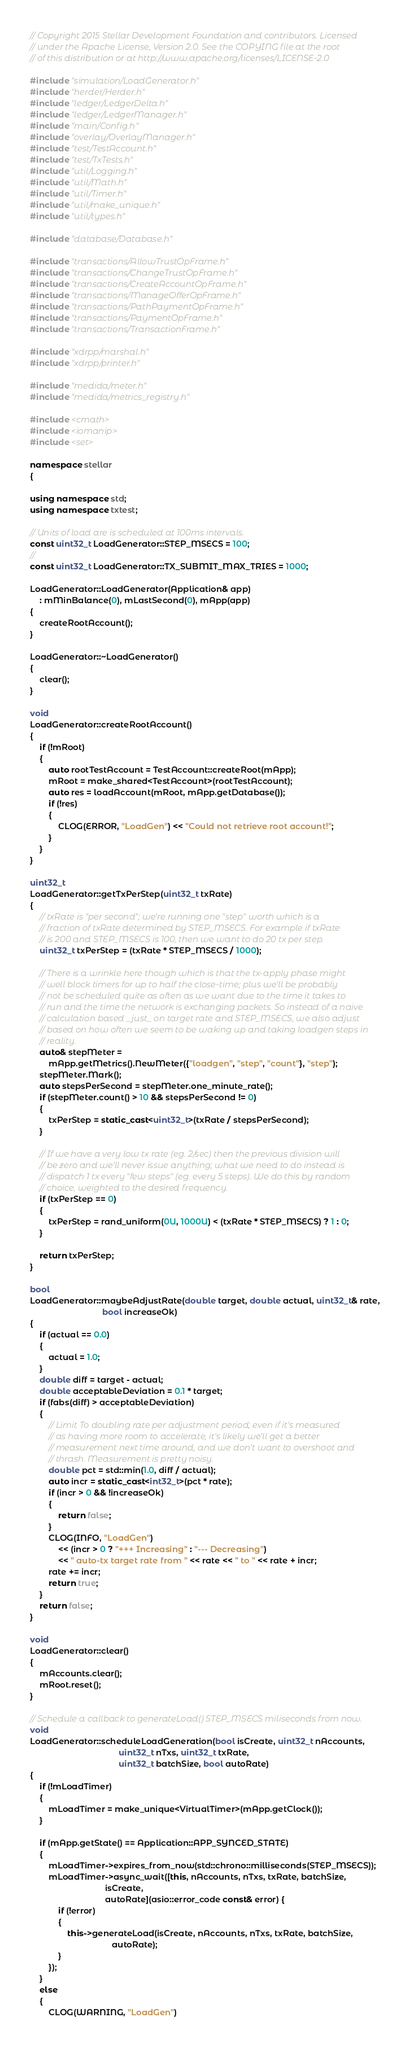<code> <loc_0><loc_0><loc_500><loc_500><_C++_>// Copyright 2015 Stellar Development Foundation and contributors. Licensed
// under the Apache License, Version 2.0. See the COPYING file at the root
// of this distribution or at http://www.apache.org/licenses/LICENSE-2.0

#include "simulation/LoadGenerator.h"
#include "herder/Herder.h"
#include "ledger/LedgerDelta.h"
#include "ledger/LedgerManager.h"
#include "main/Config.h"
#include "overlay/OverlayManager.h"
#include "test/TestAccount.h"
#include "test/TxTests.h"
#include "util/Logging.h"
#include "util/Math.h"
#include "util/Timer.h"
#include "util/make_unique.h"
#include "util/types.h"

#include "database/Database.h"

#include "transactions/AllowTrustOpFrame.h"
#include "transactions/ChangeTrustOpFrame.h"
#include "transactions/CreateAccountOpFrame.h"
#include "transactions/ManageOfferOpFrame.h"
#include "transactions/PathPaymentOpFrame.h"
#include "transactions/PaymentOpFrame.h"
#include "transactions/TransactionFrame.h"

#include "xdrpp/marshal.h"
#include "xdrpp/printer.h"

#include "medida/meter.h"
#include "medida/metrics_registry.h"

#include <cmath>
#include <iomanip>
#include <set>

namespace stellar
{

using namespace std;
using namespace txtest;

// Units of load are is scheduled at 100ms intervals.
const uint32_t LoadGenerator::STEP_MSECS = 100;
//
const uint32_t LoadGenerator::TX_SUBMIT_MAX_TRIES = 1000;

LoadGenerator::LoadGenerator(Application& app)
    : mMinBalance(0), mLastSecond(0), mApp(app)
{
    createRootAccount();
}

LoadGenerator::~LoadGenerator()
{
    clear();
}

void
LoadGenerator::createRootAccount()
{
    if (!mRoot)
    {
        auto rootTestAccount = TestAccount::createRoot(mApp);
        mRoot = make_shared<TestAccount>(rootTestAccount);
        auto res = loadAccount(mRoot, mApp.getDatabase());
        if (!res)
        {
            CLOG(ERROR, "LoadGen") << "Could not retrieve root account!";
        }
    }
}

uint32_t
LoadGenerator::getTxPerStep(uint32_t txRate)
{
    // txRate is "per second"; we're running one "step" worth which is a
    // fraction of txRate determined by STEP_MSECS. For example if txRate
    // is 200 and STEP_MSECS is 100, then we want to do 20 tx per step.
    uint32_t txPerStep = (txRate * STEP_MSECS / 1000);

    // There is a wrinkle here though which is that the tx-apply phase might
    // well block timers for up to half the close-time; plus we'll be probably
    // not be scheduled quite as often as we want due to the time it takes to
    // run and the time the network is exchanging packets. So instead of a naive
    // calculation based _just_ on target rate and STEP_MSECS, we also adjust
    // based on how often we seem to be waking up and taking loadgen steps in
    // reality.
    auto& stepMeter =
        mApp.getMetrics().NewMeter({"loadgen", "step", "count"}, "step");
    stepMeter.Mark();
    auto stepsPerSecond = stepMeter.one_minute_rate();
    if (stepMeter.count() > 10 && stepsPerSecond != 0)
    {
        txPerStep = static_cast<uint32_t>(txRate / stepsPerSecond);
    }

    // If we have a very low tx rate (eg. 2/sec) then the previous division will
    // be zero and we'll never issue anything; what we need to do instead is
    // dispatch 1 tx every "few steps" (eg. every 5 steps). We do this by random
    // choice, weighted to the desired frequency.
    if (txPerStep == 0)
    {
        txPerStep = rand_uniform(0U, 1000U) < (txRate * STEP_MSECS) ? 1 : 0;
    }

    return txPerStep;
}

bool
LoadGenerator::maybeAdjustRate(double target, double actual, uint32_t& rate,
                               bool increaseOk)
{
    if (actual == 0.0)
    {
        actual = 1.0;
    }
    double diff = target - actual;
    double acceptableDeviation = 0.1 * target;
    if (fabs(diff) > acceptableDeviation)
    {
        // Limit To doubling rate per adjustment period; even if it's measured
        // as having more room to accelerate, it's likely we'll get a better
        // measurement next time around, and we don't want to overshoot and
        // thrash. Measurement is pretty noisy.
        double pct = std::min(1.0, diff / actual);
        auto incr = static_cast<int32_t>(pct * rate);
        if (incr > 0 && !increaseOk)
        {
            return false;
        }
        CLOG(INFO, "LoadGen")
            << (incr > 0 ? "+++ Increasing" : "--- Decreasing")
            << " auto-tx target rate from " << rate << " to " << rate + incr;
        rate += incr;
        return true;
    }
    return false;
}

void
LoadGenerator::clear()
{
    mAccounts.clear();
    mRoot.reset();
}

// Schedule a callback to generateLoad() STEP_MSECS miliseconds from now.
void
LoadGenerator::scheduleLoadGeneration(bool isCreate, uint32_t nAccounts,
                                      uint32_t nTxs, uint32_t txRate,
                                      uint32_t batchSize, bool autoRate)
{
    if (!mLoadTimer)
    {
        mLoadTimer = make_unique<VirtualTimer>(mApp.getClock());
    }

    if (mApp.getState() == Application::APP_SYNCED_STATE)
    {
        mLoadTimer->expires_from_now(std::chrono::milliseconds(STEP_MSECS));
        mLoadTimer->async_wait([this, nAccounts, nTxs, txRate, batchSize,
                                isCreate,
                                autoRate](asio::error_code const& error) {
            if (!error)
            {
                this->generateLoad(isCreate, nAccounts, nTxs, txRate, batchSize,
                                   autoRate);
            }
        });
    }
    else
    {
        CLOG(WARNING, "LoadGen")</code> 